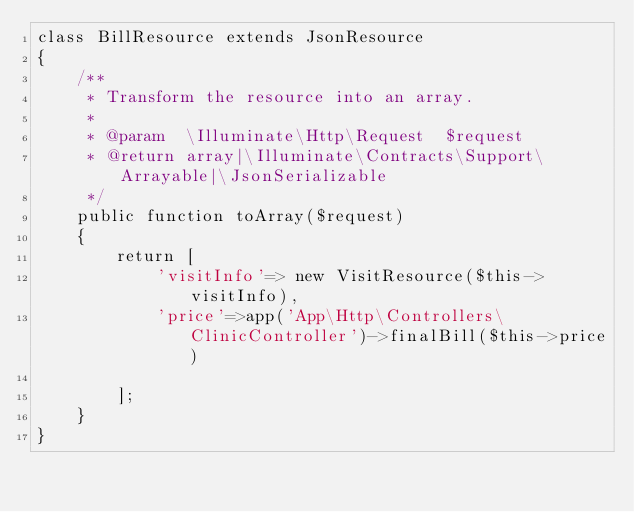Convert code to text. <code><loc_0><loc_0><loc_500><loc_500><_PHP_>class BillResource extends JsonResource
{
    /**
     * Transform the resource into an array.
     *
     * @param  \Illuminate\Http\Request  $request
     * @return array|\Illuminate\Contracts\Support\Arrayable|\JsonSerializable
     */
    public function toArray($request)
    {
        return [
            'visitInfo'=> new VisitResource($this->visitInfo),
            'price'=>app('App\Http\Controllers\ClinicController')->finalBill($this->price)

        ];
    }
}
</code> 